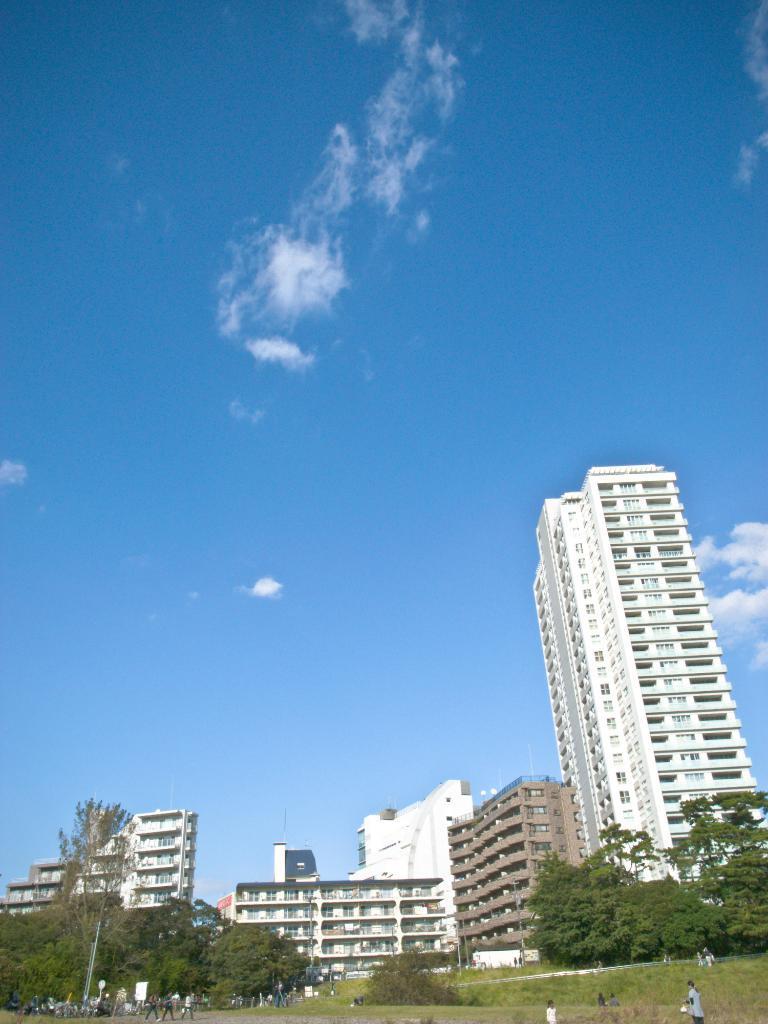In one or two sentences, can you explain what this image depicts? In this picture I can see few buildings, trees and I can see few people walking and few are standing and a blue cloudy sky. 